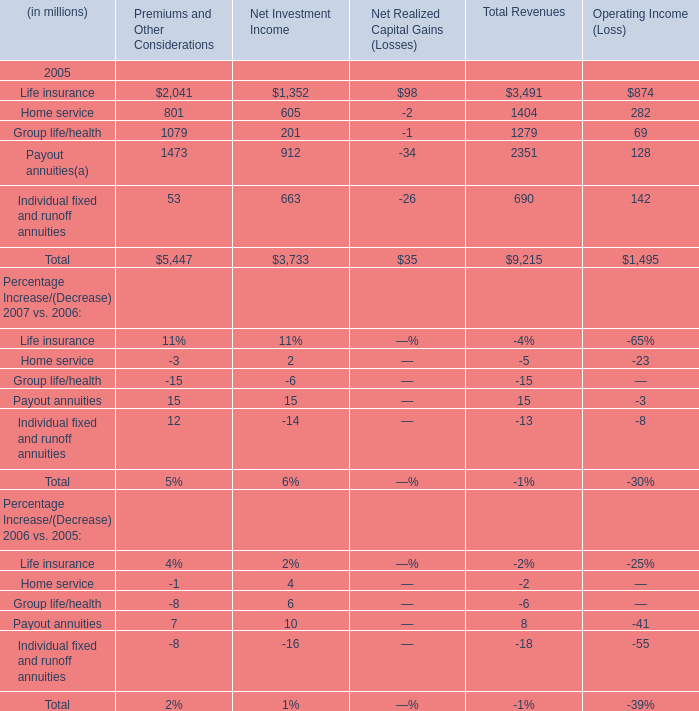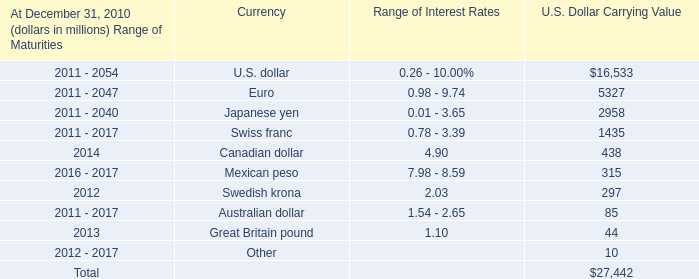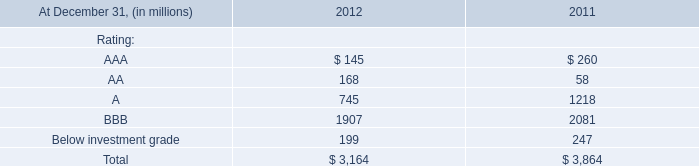What is the ratio of Life insurance to the total in 2005 for Premiums and Other Considerations? 
Computations: (2041 / 5447)
Answer: 0.3747. 